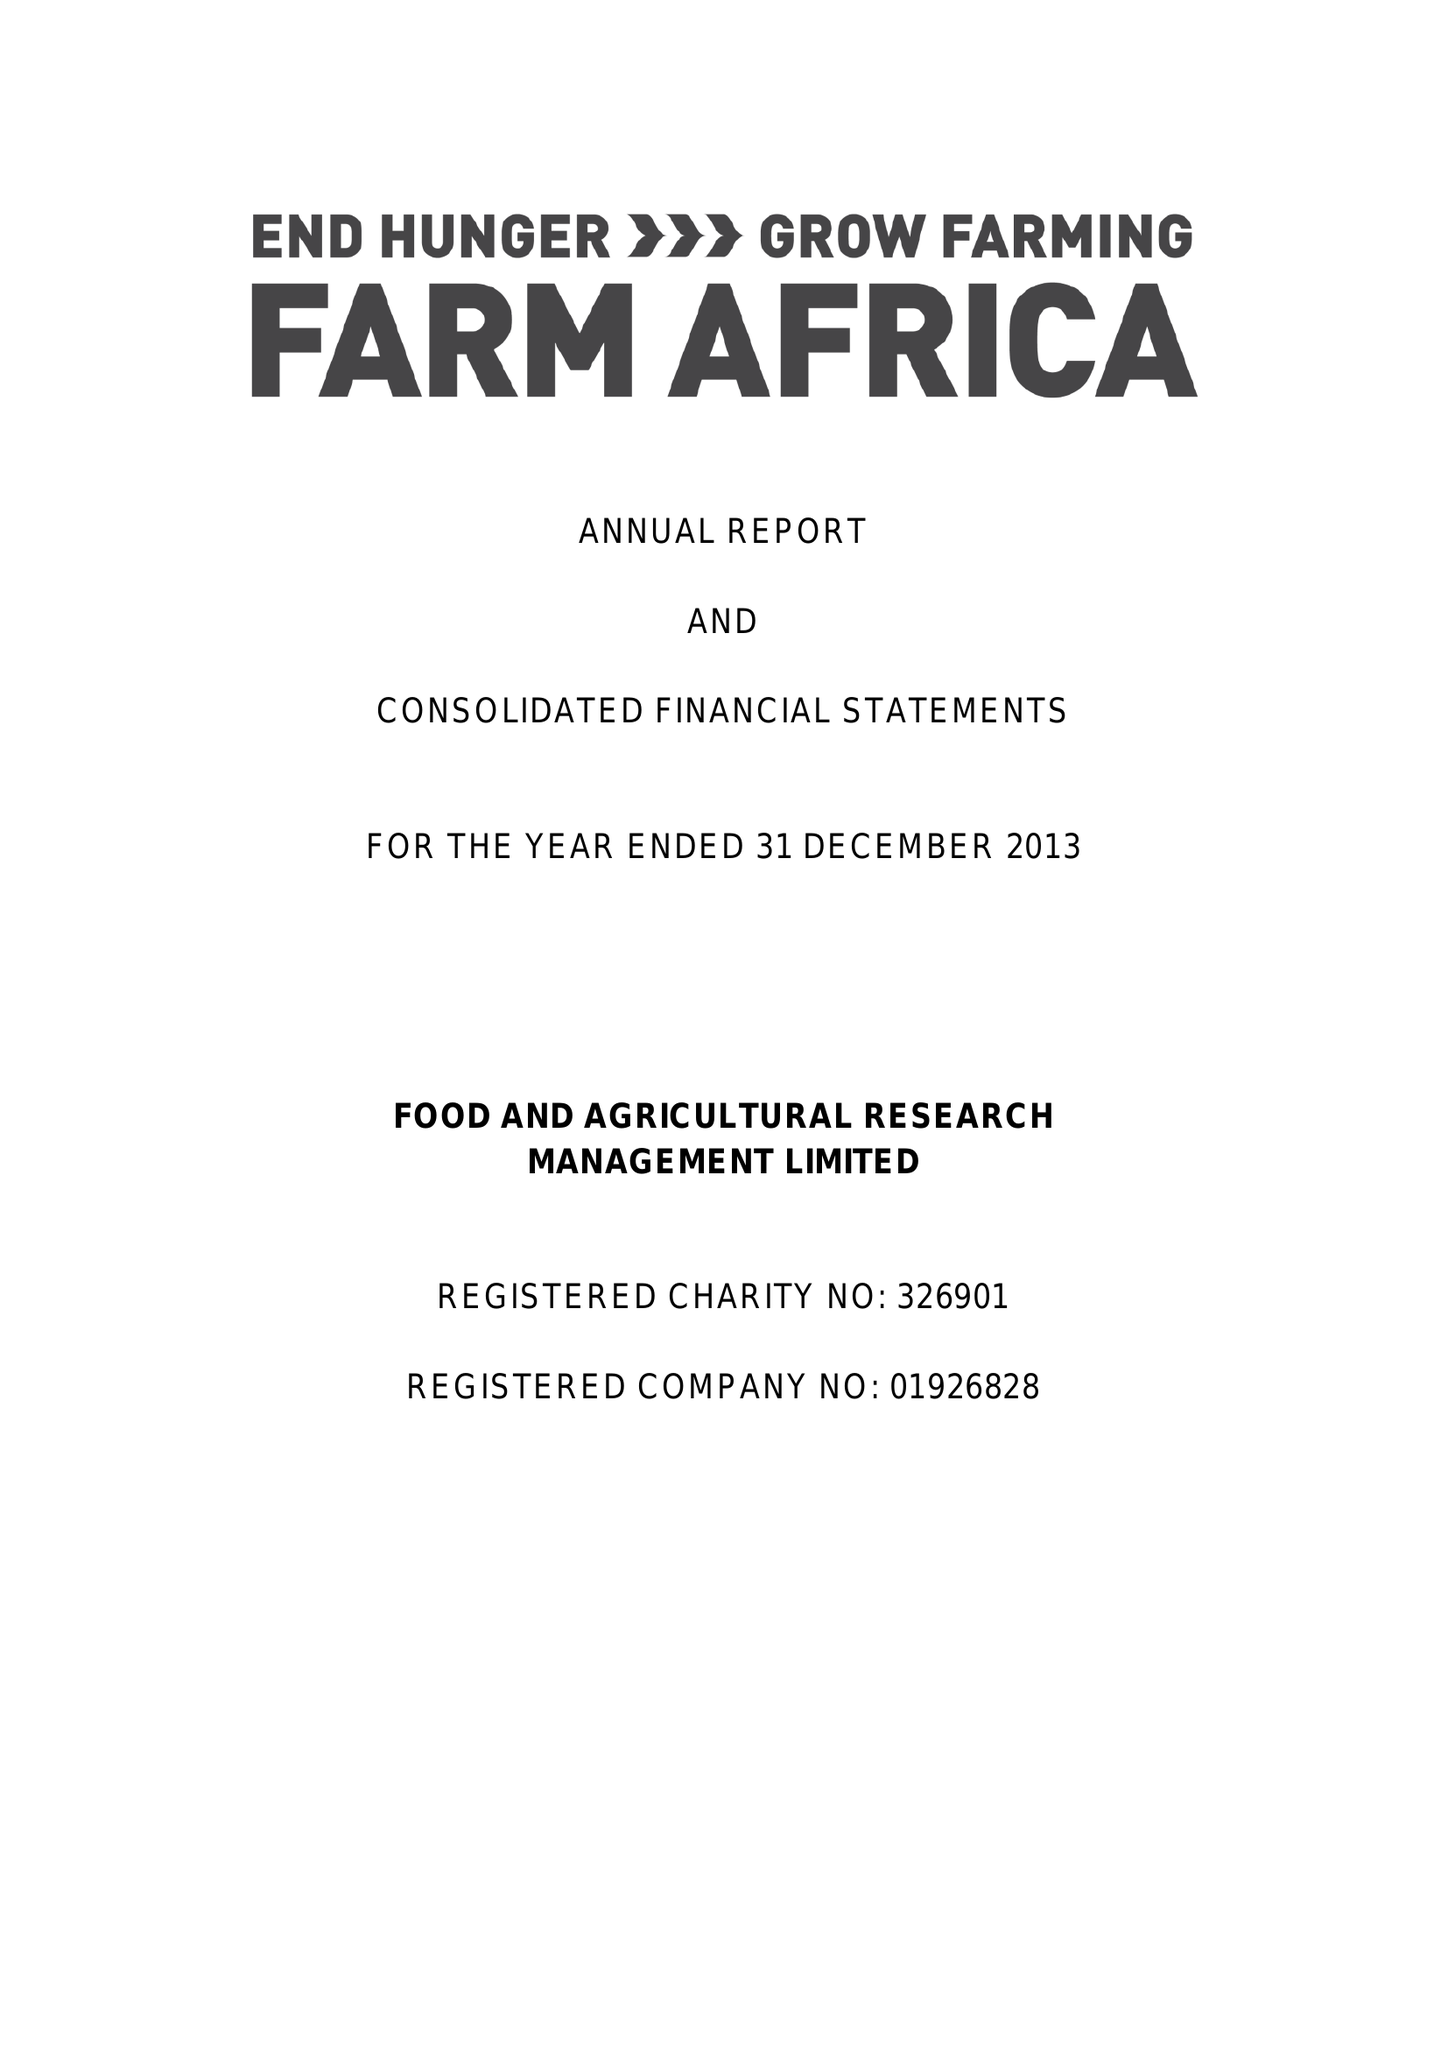What is the value for the charity_name?
Answer the question using a single word or phrase. Farm Africa Ltd. 